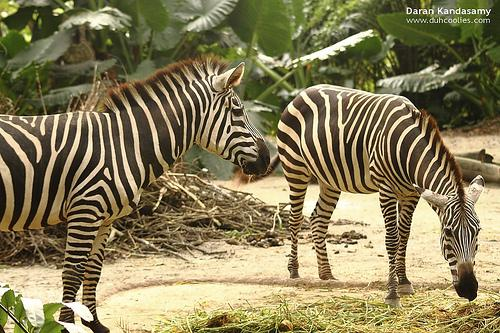Question: what animals are pictured?
Choices:
A. Horses.
B. Cows.
C. Tigers.
D. Zebra.
Answer with the letter. Answer: D Question: what is the zebra on the left doing?
Choices:
A. Sleeping.
B. Sneezing.
C. Grazing.
D. Jumping.
Answer with the letter. Answer: C Question: what color are the zebra?
Choices:
A. White.
B. Black.
C. Black and white.
D. Grey.
Answer with the letter. Answer: C Question: what is in the background?
Choices:
A. Foliage.
B. A bridge.
C. A building.
D. A billboard.
Answer with the letter. Answer: A Question: where are the zebra?
Choices:
A. In the zoo.
B. In nature.
C. In water.
D. Behind the tree.
Answer with the letter. Answer: B Question: who is in the picture?
Choices:
A. No one is in the picture.
B. Tom Brady.
C. Gisele.
D. Bill Clinton.
Answer with the letter. Answer: A 